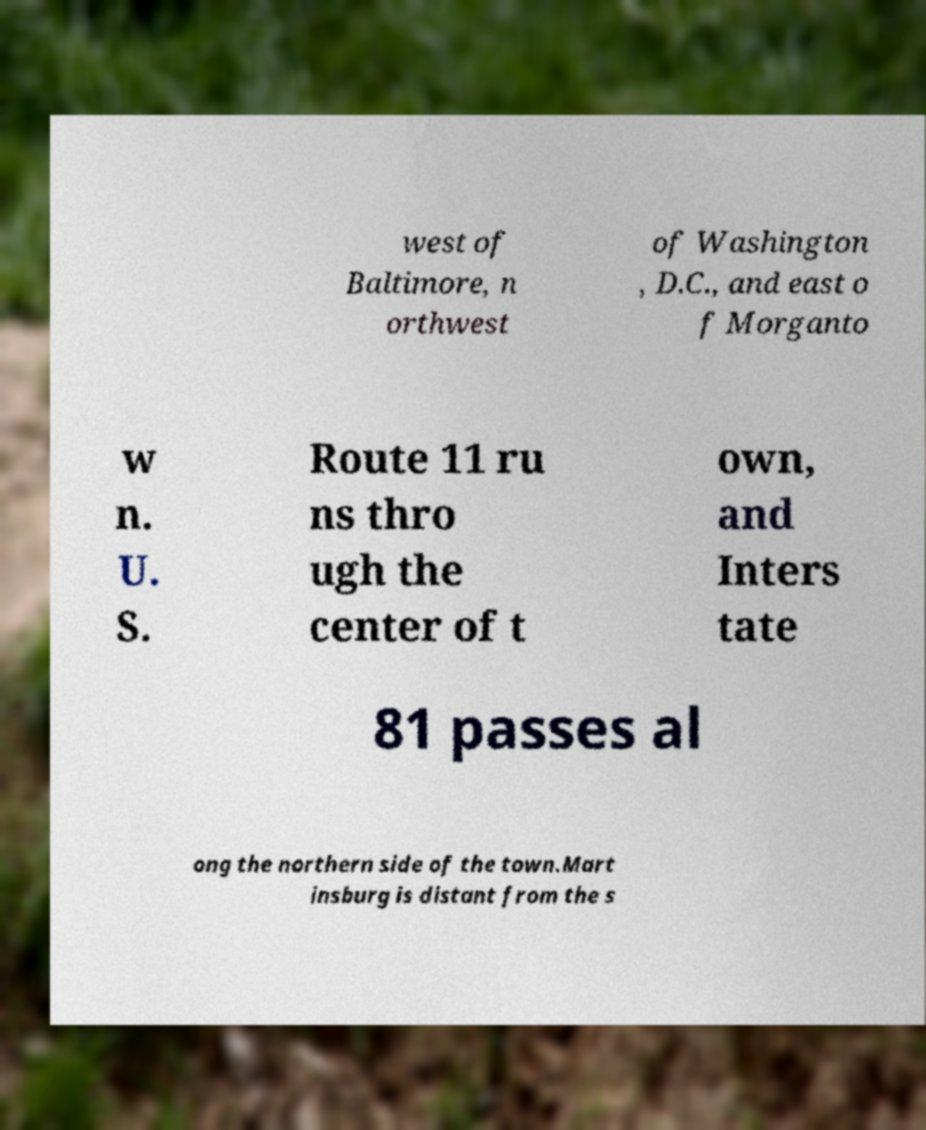Please identify and transcribe the text found in this image. west of Baltimore, n orthwest of Washington , D.C., and east o f Morganto w n. U. S. Route 11 ru ns thro ugh the center of t own, and Inters tate 81 passes al ong the northern side of the town.Mart insburg is distant from the s 